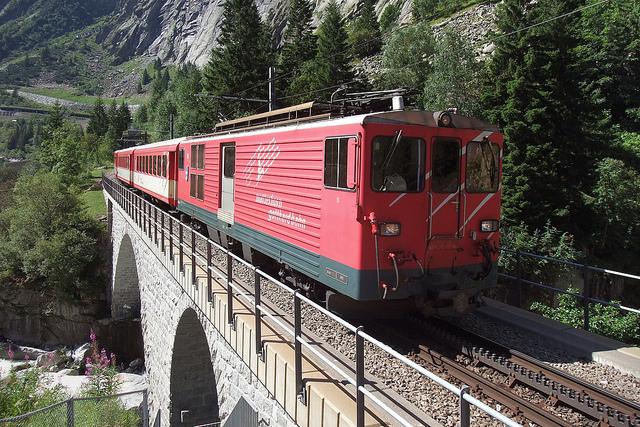Do you see high mountains?
Quick response, please. Yes. What does it say on the side of the train?
Give a very brief answer. I can't read it. What is the train driving over?
Concise answer only. Bridge. What color is the train?
Be succinct. Red. 